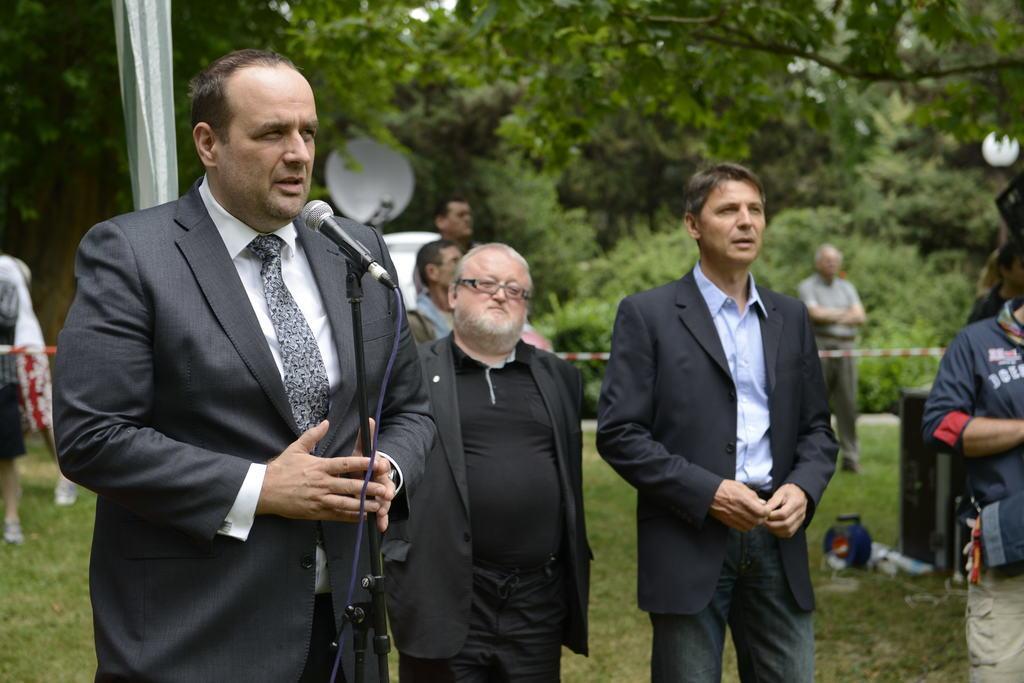Describe this image in one or two sentences. In this image we can see a person standing beside a mic holding its stand. We can also see a group of people standing, some objects and a speaker box placed on the ground. We can also see some grass, a ribbon, dish, bulb, the flag and a group of trees. 